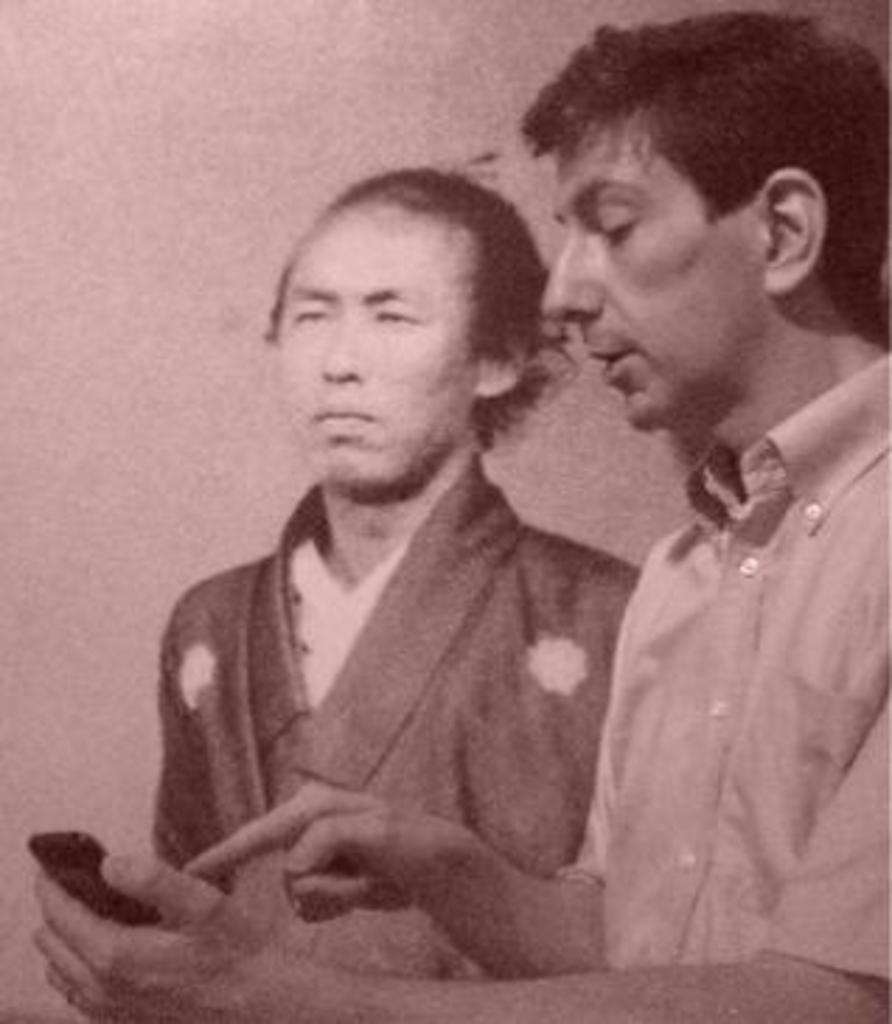How many people are in the image? There are two persons in the image. What is the person on the right side holding? The person on the right side is holding a mobile. What is the person on the right side doing with the mobile? The person on the right side is pointing the phone with his finger. What type of knee injury is the person on the left side experiencing in the image? There is no indication of a knee injury in the image; both persons appear to be standing without any visible injuries. 